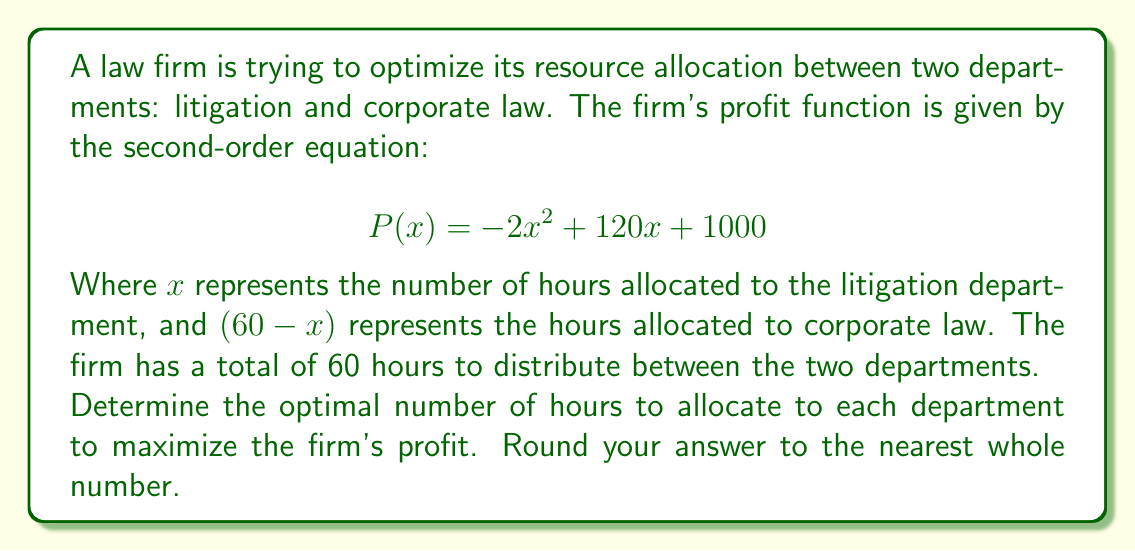Teach me how to tackle this problem. To find the optimal solution, we need to follow these steps:

1) The profit function $P(x)$ is a quadratic equation, and its graph is a parabola. The maximum point of this parabola will give us the optimal allocation.

2) To find the maximum point, we need to find the vertex of the parabola. We can do this by finding where the derivative of $P(x)$ equals zero.

3) Let's find the derivative of $P(x)$:

   $$P'(x) = -4x + 120$$

4) Set $P'(x) = 0$ and solve for $x$:

   $$-4x + 120 = 0$$
   $$-4x = -120$$
   $$x = 30$$

5) This critical point $(30, P(30))$ is the vertex of the parabola and represents the maximum profit.

6) To verify it's a maximum, we can check the second derivative:
   
   $$P''(x) = -4$$

   Since $P''(x)$ is negative, this confirms that $x = 30$ gives a maximum.

7) Calculate the profit at this point:

   $$P(30) = -2(30)^2 + 120(30) + 1000 = -1800 + 3600 + 1000 = 2800$$

8) Therefore, the optimal allocation is 30 hours to litigation and 30 hours to corporate law (60 - 30 = 30).
Answer: The optimal allocation is 30 hours to the litigation department and 30 hours to the corporate law department, resulting in a maximum profit of $2800. 